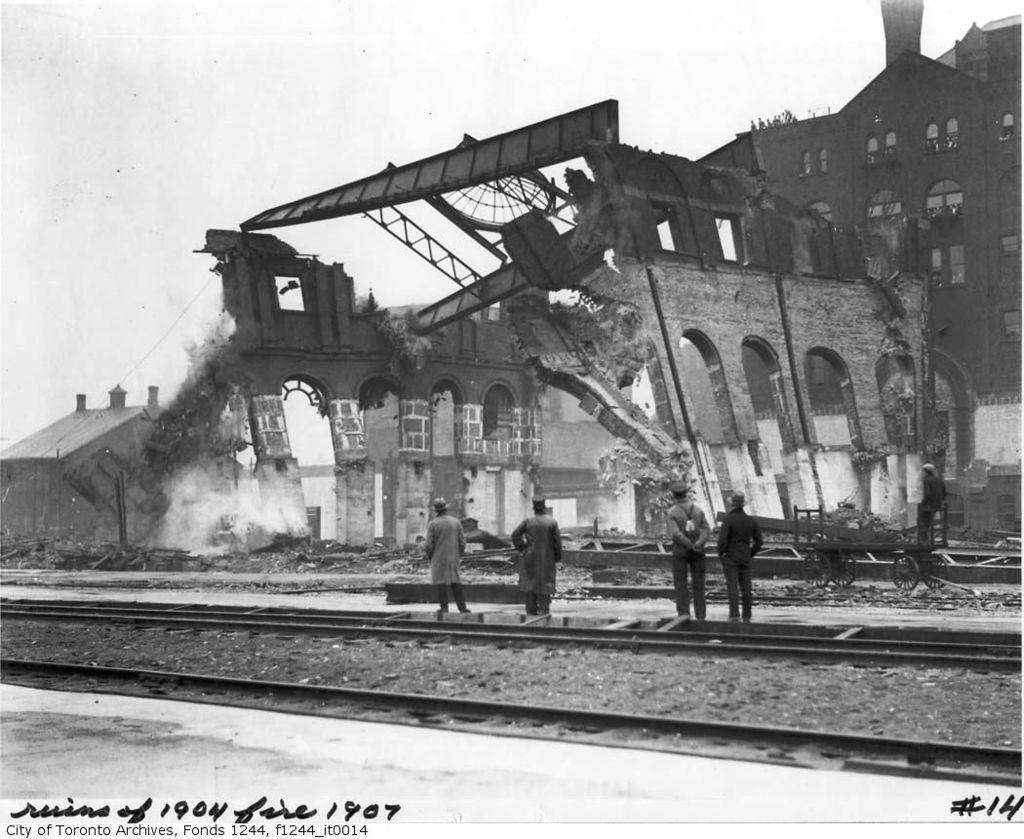How would you summarize this image in a sentence or two? In this image we can see a destructed building and a building at the back and a a building on the left side and there are few people standing on the platform, there is a railway track, a cart and the sky in the background. 